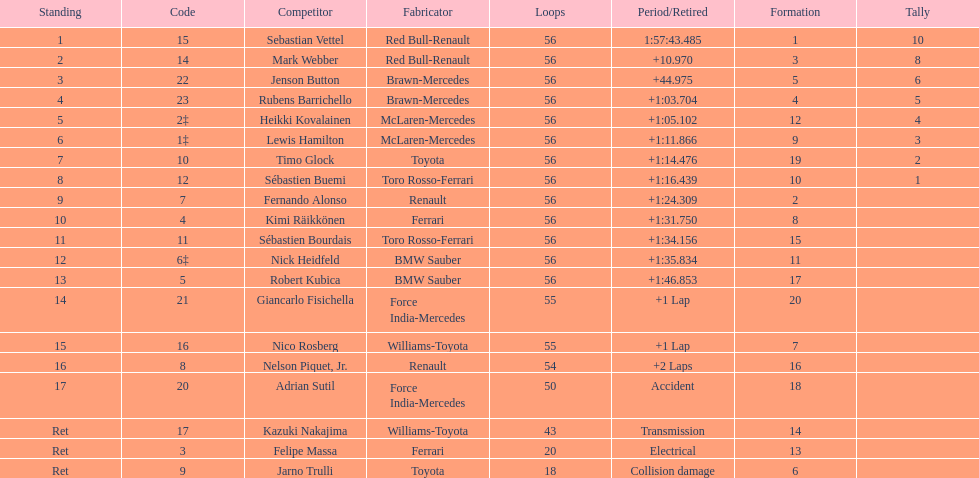What driver was last on the list? Jarno Trulli. 